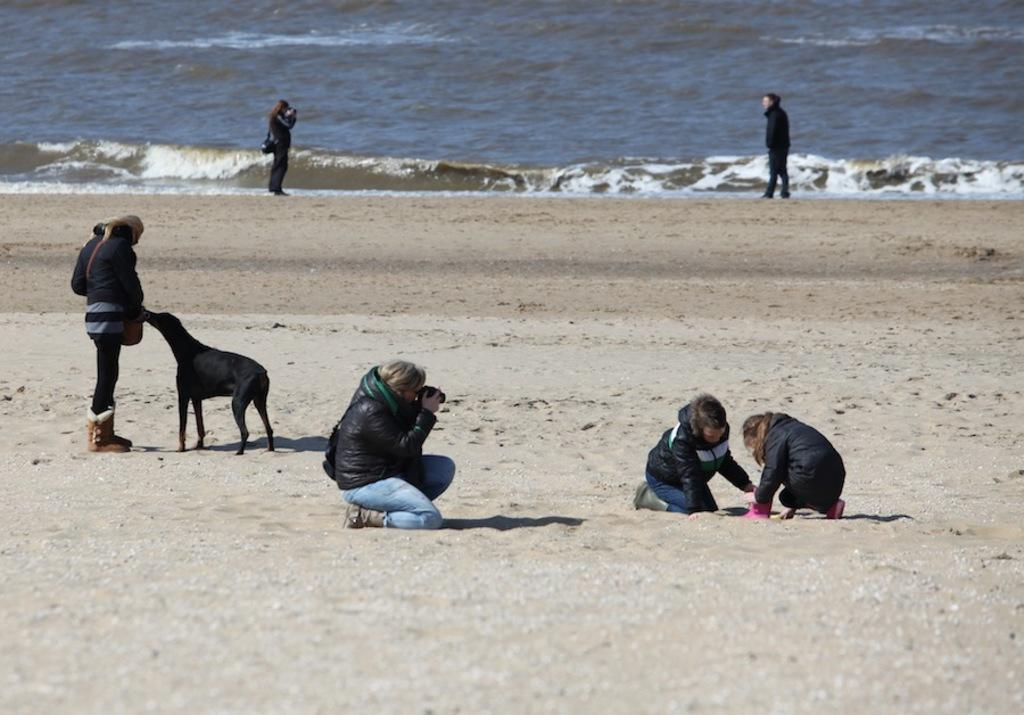Who or what can be seen in the image? There are people and a dog in the image. What type of surface is visible in the image? The sand is visible in the image. Where are the people located in relation to the water? The people are near the water in the image. What is the other main element visible in the image? The water is visible in the image. What type of meat is being served for dinner in the image? There is no dinner or meat present in the image. 